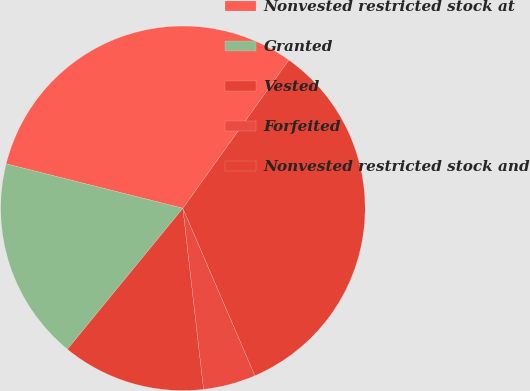Convert chart. <chart><loc_0><loc_0><loc_500><loc_500><pie_chart><fcel>Nonvested restricted stock at<fcel>Granted<fcel>Vested<fcel>Forfeited<fcel>Nonvested restricted stock and<nl><fcel>30.96%<fcel>18.0%<fcel>12.73%<fcel>4.66%<fcel>33.65%<nl></chart> 